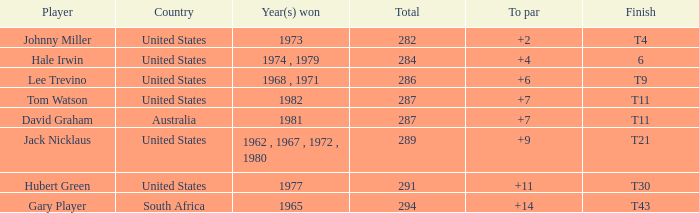WHAT IS THE TO PAR WITH A FINISH OF T11, FOR DAVID GRAHAM? 7.0. 